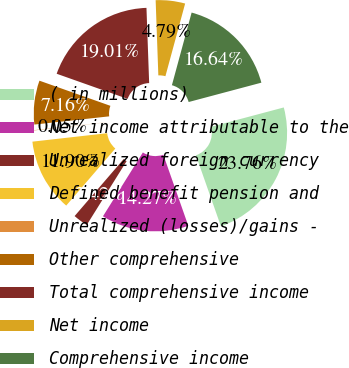Convert chart. <chart><loc_0><loc_0><loc_500><loc_500><pie_chart><fcel>( in millions)<fcel>Net income attributable to the<fcel>Unrealized foreign currency<fcel>Defined benefit pension and<fcel>Unrealized (losses)/gains -<fcel>Other comprehensive<fcel>Total comprehensive income<fcel>Net income<fcel>Comprehensive income<nl><fcel>23.76%<fcel>14.27%<fcel>2.42%<fcel>11.9%<fcel>0.05%<fcel>7.16%<fcel>19.01%<fcel>4.79%<fcel>16.64%<nl></chart> 